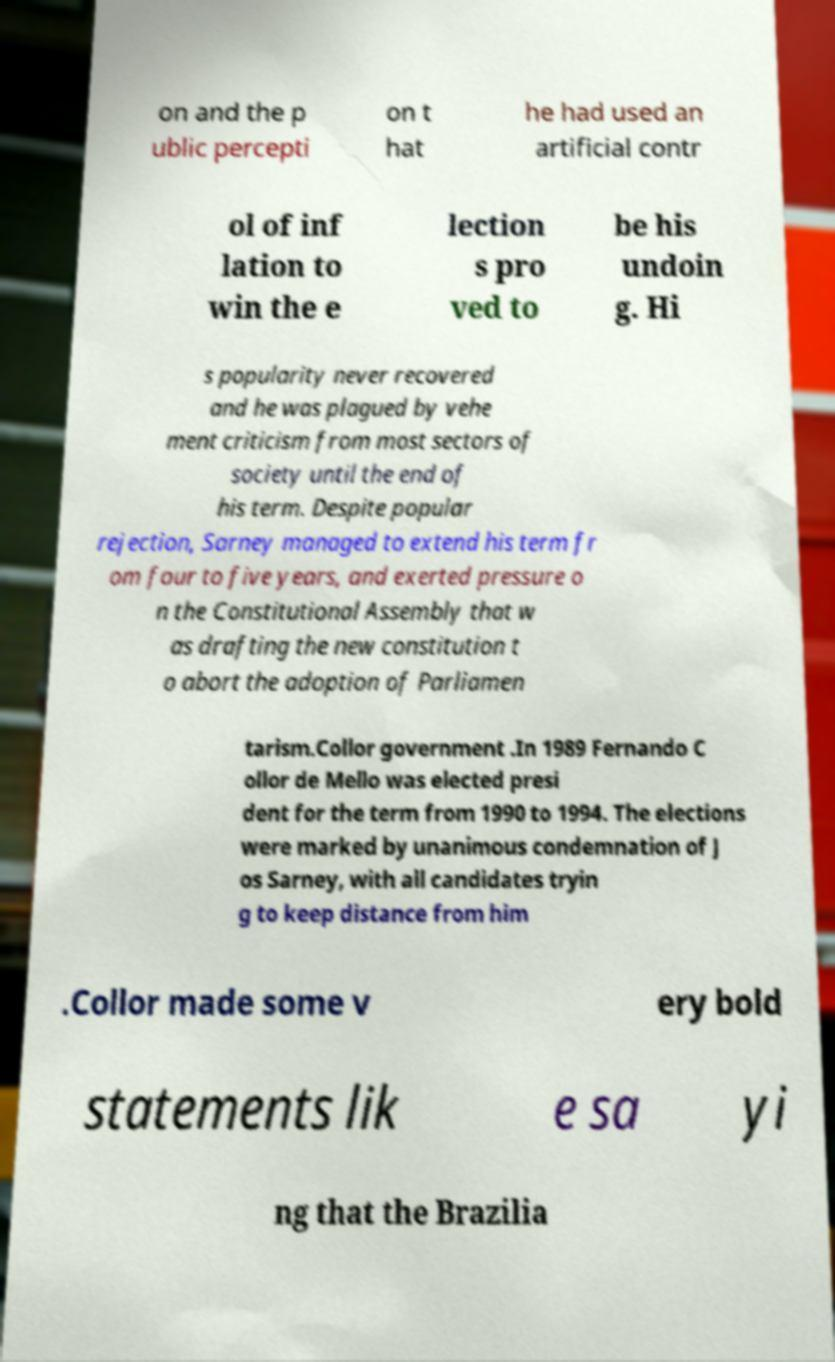Can you accurately transcribe the text from the provided image for me? on and the p ublic percepti on t hat he had used an artificial contr ol of inf lation to win the e lection s pro ved to be his undoin g. Hi s popularity never recovered and he was plagued by vehe ment criticism from most sectors of society until the end of his term. Despite popular rejection, Sarney managed to extend his term fr om four to five years, and exerted pressure o n the Constitutional Assembly that w as drafting the new constitution t o abort the adoption of Parliamen tarism.Collor government .In 1989 Fernando C ollor de Mello was elected presi dent for the term from 1990 to 1994. The elections were marked by unanimous condemnation of J os Sarney, with all candidates tryin g to keep distance from him .Collor made some v ery bold statements lik e sa yi ng that the Brazilia 